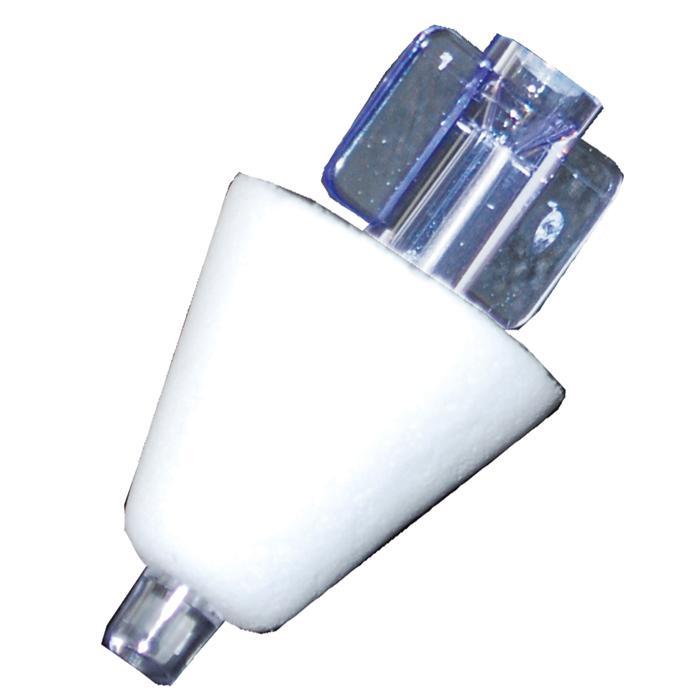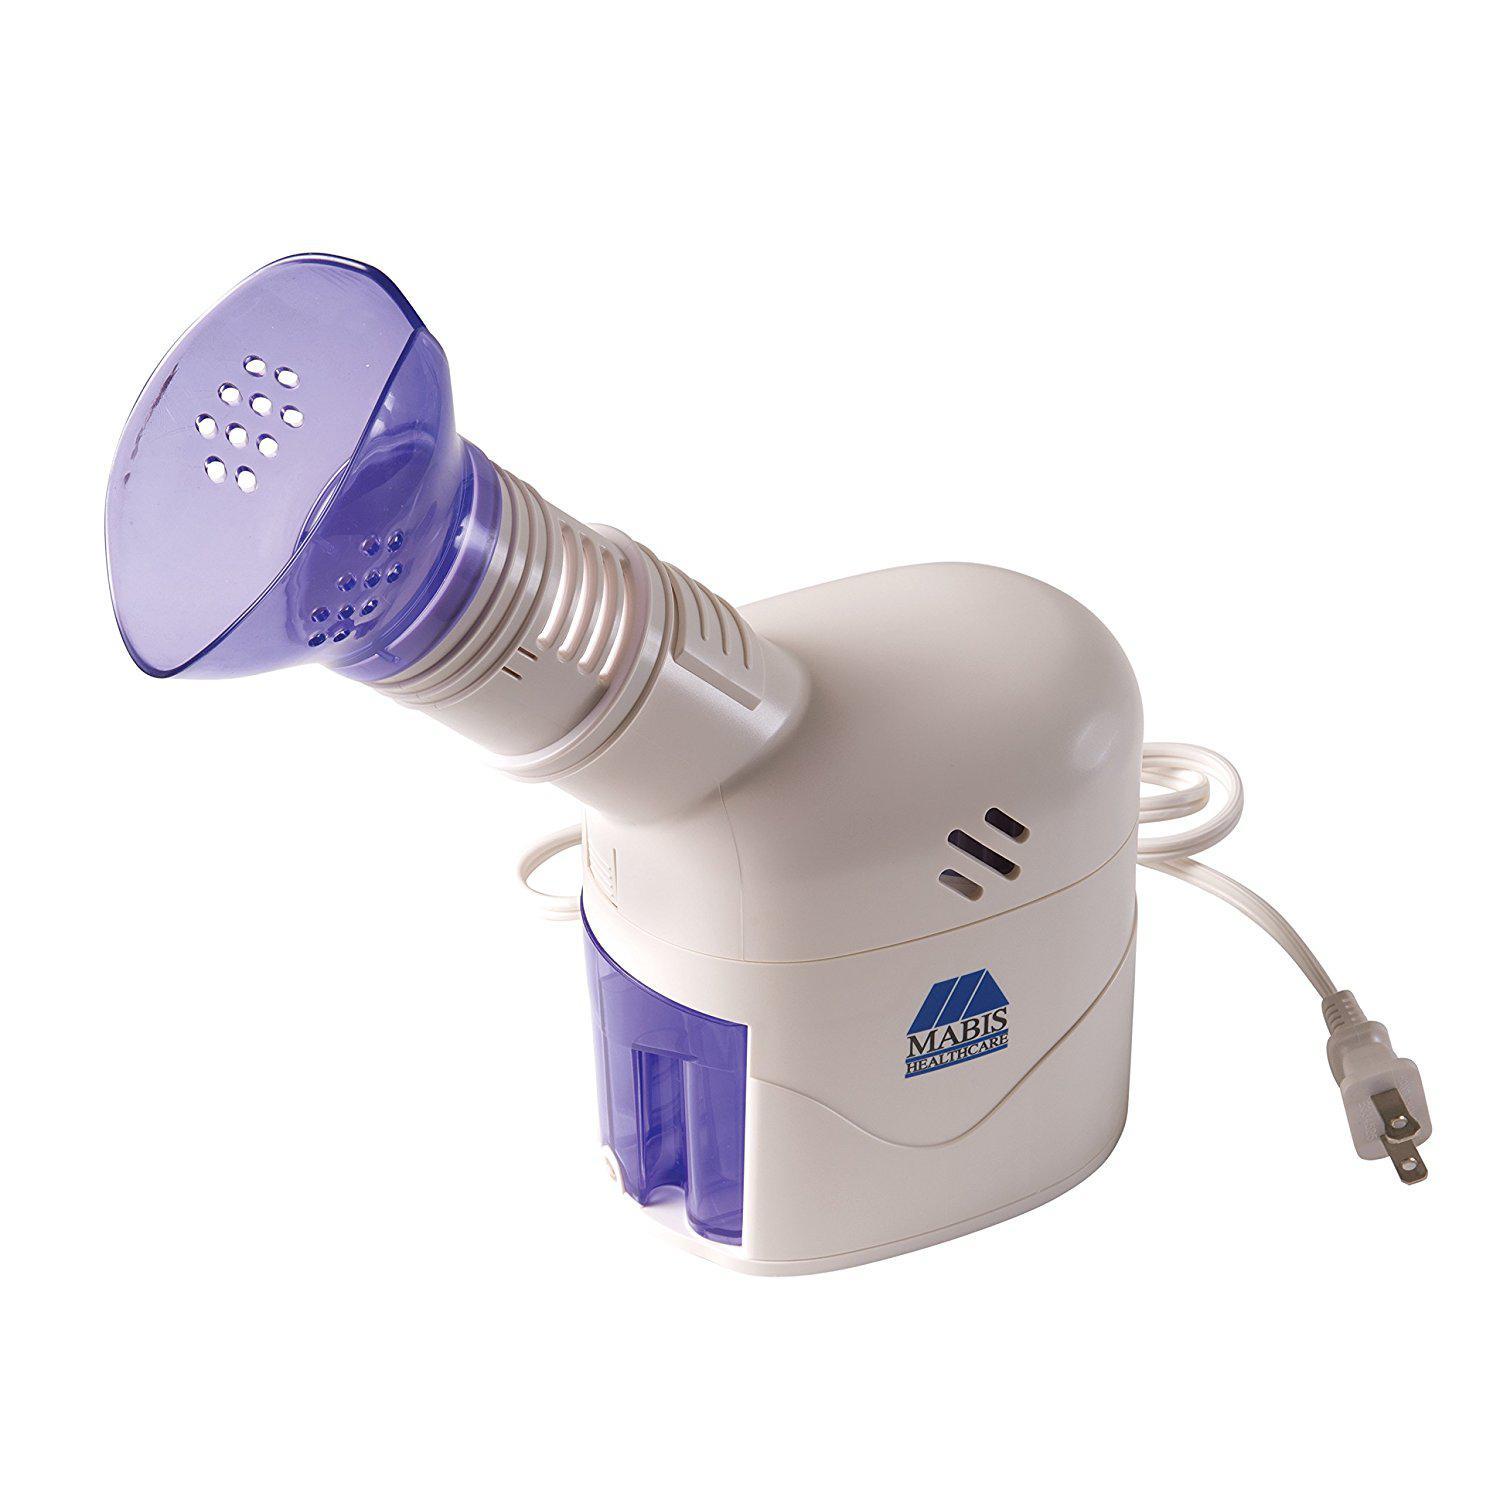The first image is the image on the left, the second image is the image on the right. Assess this claim about the two images: "The image on the right contains a cone.". Correct or not? Answer yes or no. No. 